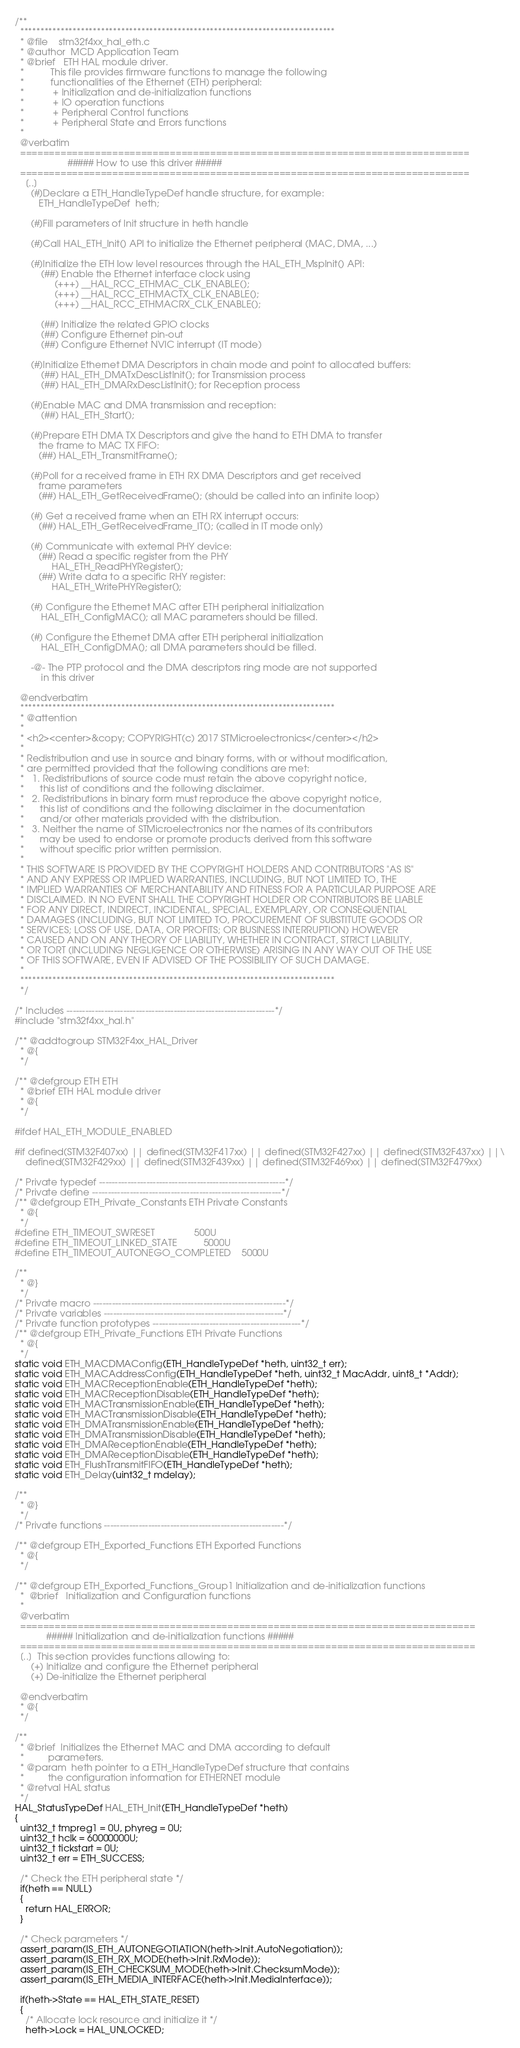<code> <loc_0><loc_0><loc_500><loc_500><_C_>/**
  ******************************************************************************
  * @file    stm32f4xx_hal_eth.c
  * @author  MCD Application Team
  * @brief   ETH HAL module driver.
  *          This file provides firmware functions to manage the following
  *          functionalities of the Ethernet (ETH) peripheral:
  *           + Initialization and de-initialization functions
  *           + IO operation functions
  *           + Peripheral Control functions
  *           + Peripheral State and Errors functions
  *
  @verbatim
  ==============================================================================
                    ##### How to use this driver #####
  ==============================================================================
    [..]
      (#)Declare a ETH_HandleTypeDef handle structure, for example:
         ETH_HandleTypeDef  heth;

      (#)Fill parameters of Init structure in heth handle

      (#)Call HAL_ETH_Init() API to initialize the Ethernet peripheral (MAC, DMA, ...)

      (#)Initialize the ETH low level resources through the HAL_ETH_MspInit() API:
          (##) Enable the Ethernet interface clock using
               (+++) __HAL_RCC_ETHMAC_CLK_ENABLE();
               (+++) __HAL_RCC_ETHMACTX_CLK_ENABLE();
               (+++) __HAL_RCC_ETHMACRX_CLK_ENABLE();

          (##) Initialize the related GPIO clocks
          (##) Configure Ethernet pin-out
          (##) Configure Ethernet NVIC interrupt (IT mode)

      (#)Initialize Ethernet DMA Descriptors in chain mode and point to allocated buffers:
          (##) HAL_ETH_DMATxDescListInit(); for Transmission process
          (##) HAL_ETH_DMARxDescListInit(); for Reception process

      (#)Enable MAC and DMA transmission and reception:
          (##) HAL_ETH_Start();

      (#)Prepare ETH DMA TX Descriptors and give the hand to ETH DMA to transfer
         the frame to MAC TX FIFO:
         (##) HAL_ETH_TransmitFrame();

      (#)Poll for a received frame in ETH RX DMA Descriptors and get received
         frame parameters
         (##) HAL_ETH_GetReceivedFrame(); (should be called into an infinite loop)

      (#) Get a received frame when an ETH RX interrupt occurs:
         (##) HAL_ETH_GetReceivedFrame_IT(); (called in IT mode only)

      (#) Communicate with external PHY device:
         (##) Read a specific register from the PHY
              HAL_ETH_ReadPHYRegister();
         (##) Write data to a specific RHY register:
              HAL_ETH_WritePHYRegister();

      (#) Configure the Ethernet MAC after ETH peripheral initialization
          HAL_ETH_ConfigMAC(); all MAC parameters should be filled.

      (#) Configure the Ethernet DMA after ETH peripheral initialization
          HAL_ETH_ConfigDMA(); all DMA parameters should be filled.

      -@- The PTP protocol and the DMA descriptors ring mode are not supported
          in this driver

  @endverbatim
  ******************************************************************************
  * @attention
  *
  * <h2><center>&copy; COPYRIGHT(c) 2017 STMicroelectronics</center></h2>
  *
  * Redistribution and use in source and binary forms, with or without modification,
  * are permitted provided that the following conditions are met:
  *   1. Redistributions of source code must retain the above copyright notice,
  *      this list of conditions and the following disclaimer.
  *   2. Redistributions in binary form must reproduce the above copyright notice,
  *      this list of conditions and the following disclaimer in the documentation
  *      and/or other materials provided with the distribution.
  *   3. Neither the name of STMicroelectronics nor the names of its contributors
  *      may be used to endorse or promote products derived from this software
  *      without specific prior written permission.
  *
  * THIS SOFTWARE IS PROVIDED BY THE COPYRIGHT HOLDERS AND CONTRIBUTORS "AS IS"
  * AND ANY EXPRESS OR IMPLIED WARRANTIES, INCLUDING, BUT NOT LIMITED TO, THE
  * IMPLIED WARRANTIES OF MERCHANTABILITY AND FITNESS FOR A PARTICULAR PURPOSE ARE
  * DISCLAIMED. IN NO EVENT SHALL THE COPYRIGHT HOLDER OR CONTRIBUTORS BE LIABLE
  * FOR ANY DIRECT, INDIRECT, INCIDENTAL, SPECIAL, EXEMPLARY, OR CONSEQUENTIAL
  * DAMAGES (INCLUDING, BUT NOT LIMITED TO, PROCUREMENT OF SUBSTITUTE GOODS OR
  * SERVICES; LOSS OF USE, DATA, OR PROFITS; OR BUSINESS INTERRUPTION) HOWEVER
  * CAUSED AND ON ANY THEORY OF LIABILITY, WHETHER IN CONTRACT, STRICT LIABILITY,
  * OR TORT (INCLUDING NEGLIGENCE OR OTHERWISE) ARISING IN ANY WAY OUT OF THE USE
  * OF THIS SOFTWARE, EVEN IF ADVISED OF THE POSSIBILITY OF SUCH DAMAGE.
  *
  ******************************************************************************
  */

/* Includes ------------------------------------------------------------------*/
#include "stm32f4xx_hal.h"

/** @addtogroup STM32F4xx_HAL_Driver
  * @{
  */

/** @defgroup ETH ETH
  * @brief ETH HAL module driver
  * @{
  */

#ifdef HAL_ETH_MODULE_ENABLED

#if defined(STM32F407xx) || defined(STM32F417xx) || defined(STM32F427xx) || defined(STM32F437xx) ||\
    defined(STM32F429xx) || defined(STM32F439xx) || defined(STM32F469xx) || defined(STM32F479xx)

/* Private typedef -----------------------------------------------------------*/
/* Private define ------------------------------------------------------------*/
/** @defgroup ETH_Private_Constants ETH Private Constants
  * @{
  */
#define ETH_TIMEOUT_SWRESET               500U
#define ETH_TIMEOUT_LINKED_STATE          5000U
#define ETH_TIMEOUT_AUTONEGO_COMPLETED    5000U

/**
  * @}
  */
/* Private macro -------------------------------------------------------------*/
/* Private variables ---------------------------------------------------------*/
/* Private function prototypes -----------------------------------------------*/
/** @defgroup ETH_Private_Functions ETH Private Functions
  * @{
  */
static void ETH_MACDMAConfig(ETH_HandleTypeDef *heth, uint32_t err);
static void ETH_MACAddressConfig(ETH_HandleTypeDef *heth, uint32_t MacAddr, uint8_t *Addr);
static void ETH_MACReceptionEnable(ETH_HandleTypeDef *heth);
static void ETH_MACReceptionDisable(ETH_HandleTypeDef *heth);
static void ETH_MACTransmissionEnable(ETH_HandleTypeDef *heth);
static void ETH_MACTransmissionDisable(ETH_HandleTypeDef *heth);
static void ETH_DMATransmissionEnable(ETH_HandleTypeDef *heth);
static void ETH_DMATransmissionDisable(ETH_HandleTypeDef *heth);
static void ETH_DMAReceptionEnable(ETH_HandleTypeDef *heth);
static void ETH_DMAReceptionDisable(ETH_HandleTypeDef *heth);
static void ETH_FlushTransmitFIFO(ETH_HandleTypeDef *heth);
static void ETH_Delay(uint32_t mdelay);

/**
  * @}
  */
/* Private functions ---------------------------------------------------------*/

/** @defgroup ETH_Exported_Functions ETH Exported Functions
  * @{
  */

/** @defgroup ETH_Exported_Functions_Group1 Initialization and de-initialization functions
  *  @brief   Initialization and Configuration functions
  *
  @verbatim
  ===============================================================================
            ##### Initialization and de-initialization functions #####
  ===============================================================================
  [..]  This section provides functions allowing to:
      (+) Initialize and configure the Ethernet peripheral
      (+) De-initialize the Ethernet peripheral

  @endverbatim
  * @{
  */

/**
  * @brief  Initializes the Ethernet MAC and DMA according to default
  *         parameters.
  * @param  heth pointer to a ETH_HandleTypeDef structure that contains
  *         the configuration information for ETHERNET module
  * @retval HAL status
  */
HAL_StatusTypeDef HAL_ETH_Init(ETH_HandleTypeDef *heth)
{
  uint32_t tmpreg1 = 0U, phyreg = 0U;
  uint32_t hclk = 60000000U;
  uint32_t tickstart = 0U;
  uint32_t err = ETH_SUCCESS;

  /* Check the ETH peripheral state */
  if(heth == NULL)
  {
    return HAL_ERROR;
  }

  /* Check parameters */
  assert_param(IS_ETH_AUTONEGOTIATION(heth->Init.AutoNegotiation));
  assert_param(IS_ETH_RX_MODE(heth->Init.RxMode));
  assert_param(IS_ETH_CHECKSUM_MODE(heth->Init.ChecksumMode));
  assert_param(IS_ETH_MEDIA_INTERFACE(heth->Init.MediaInterface));

  if(heth->State == HAL_ETH_STATE_RESET)
  {
    /* Allocate lock resource and initialize it */
    heth->Lock = HAL_UNLOCKED;</code> 